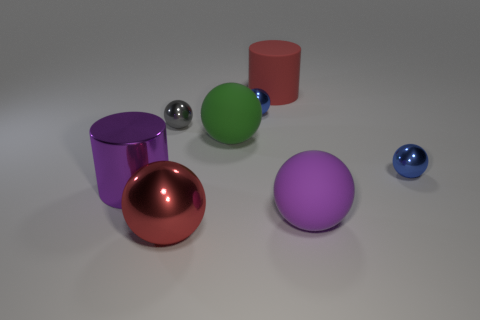How many things are right of the large metallic cylinder and in front of the gray sphere?
Provide a short and direct response. 4. How many big cylinders are in front of the tiny thing right of the large purple rubber thing?
Make the answer very short. 1. Is the size of the metal ball on the right side of the purple rubber ball the same as the cylinder in front of the gray shiny thing?
Your answer should be compact. No. How many big gray matte objects are there?
Provide a succinct answer. 0. How many large purple objects are made of the same material as the big green thing?
Offer a very short reply. 1. Are there the same number of big red spheres to the left of the big metallic sphere and blue metal things?
Ensure brevity in your answer.  No. What is the material of the large thing that is the same color as the large metallic cylinder?
Your answer should be compact. Rubber. There is a matte cylinder; does it have the same size as the purple thing right of the purple metal cylinder?
Your answer should be very brief. Yes. How many other objects are the same size as the red rubber cylinder?
Your response must be concise. 4. What number of other objects are there of the same color as the large matte cylinder?
Your answer should be very brief. 1. 